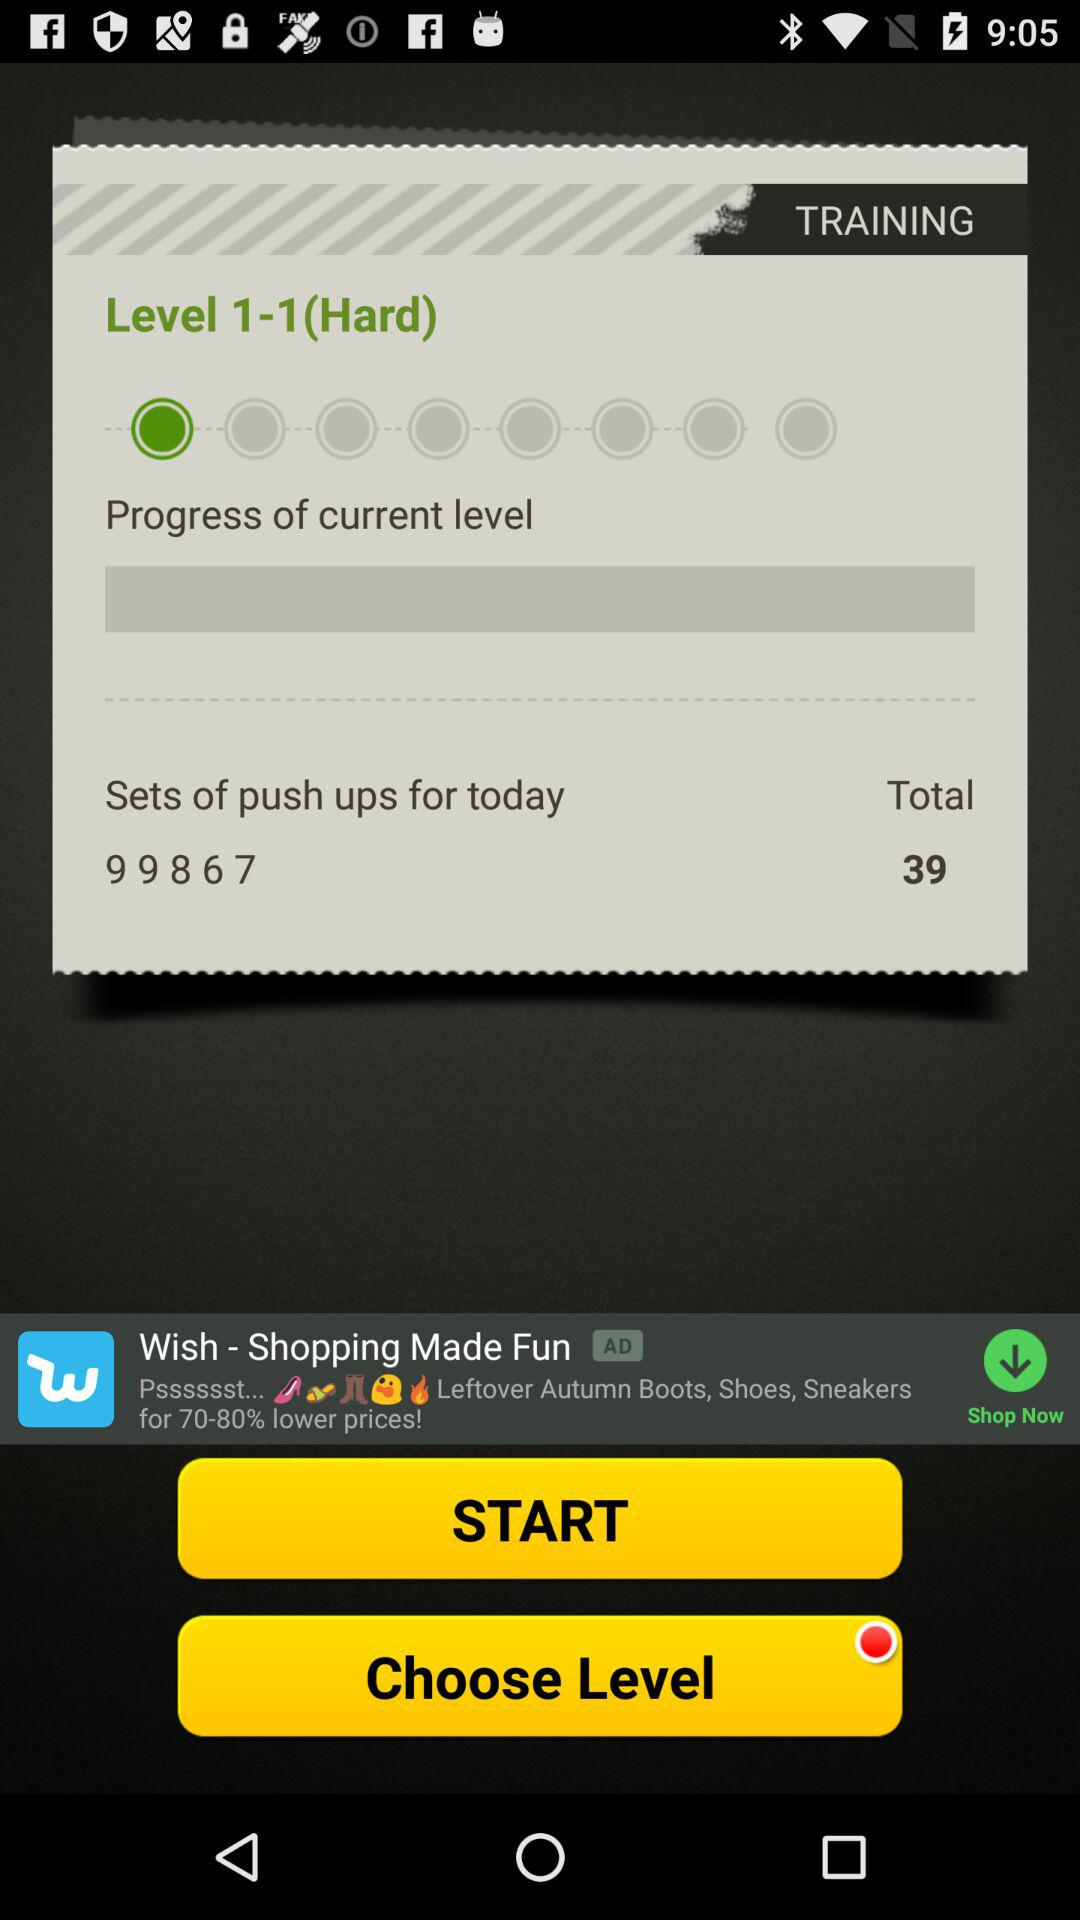What's the sets' sequence of push-ups? The sets' sequence of push-ups is 9, 9, 8, 6, and 7. 